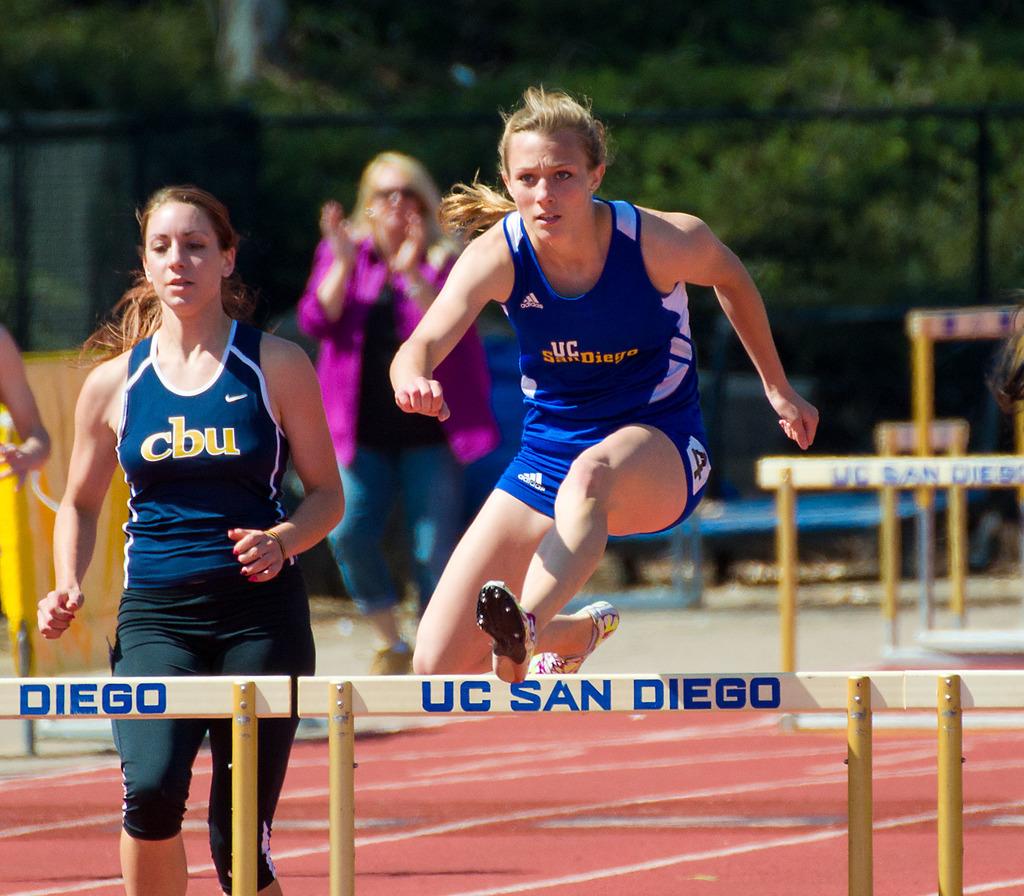What city is on the jump?
Your answer should be compact. San diego. 